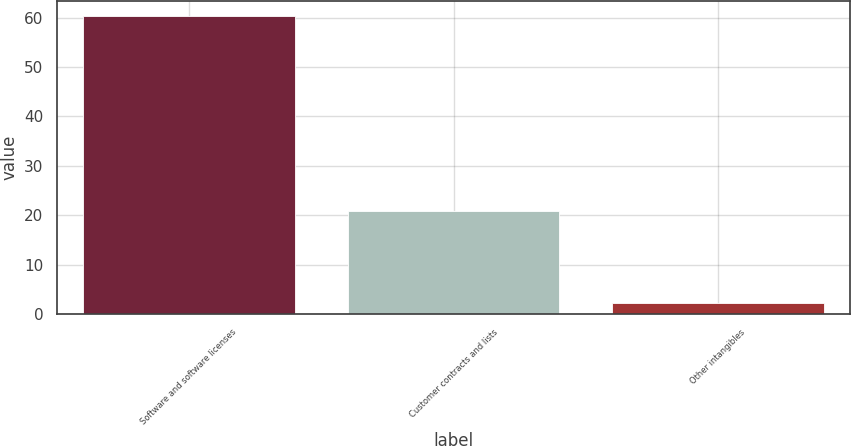Convert chart to OTSL. <chart><loc_0><loc_0><loc_500><loc_500><bar_chart><fcel>Software and software licenses<fcel>Customer contracts and lists<fcel>Other intangibles<nl><fcel>60.3<fcel>20.9<fcel>2.3<nl></chart> 